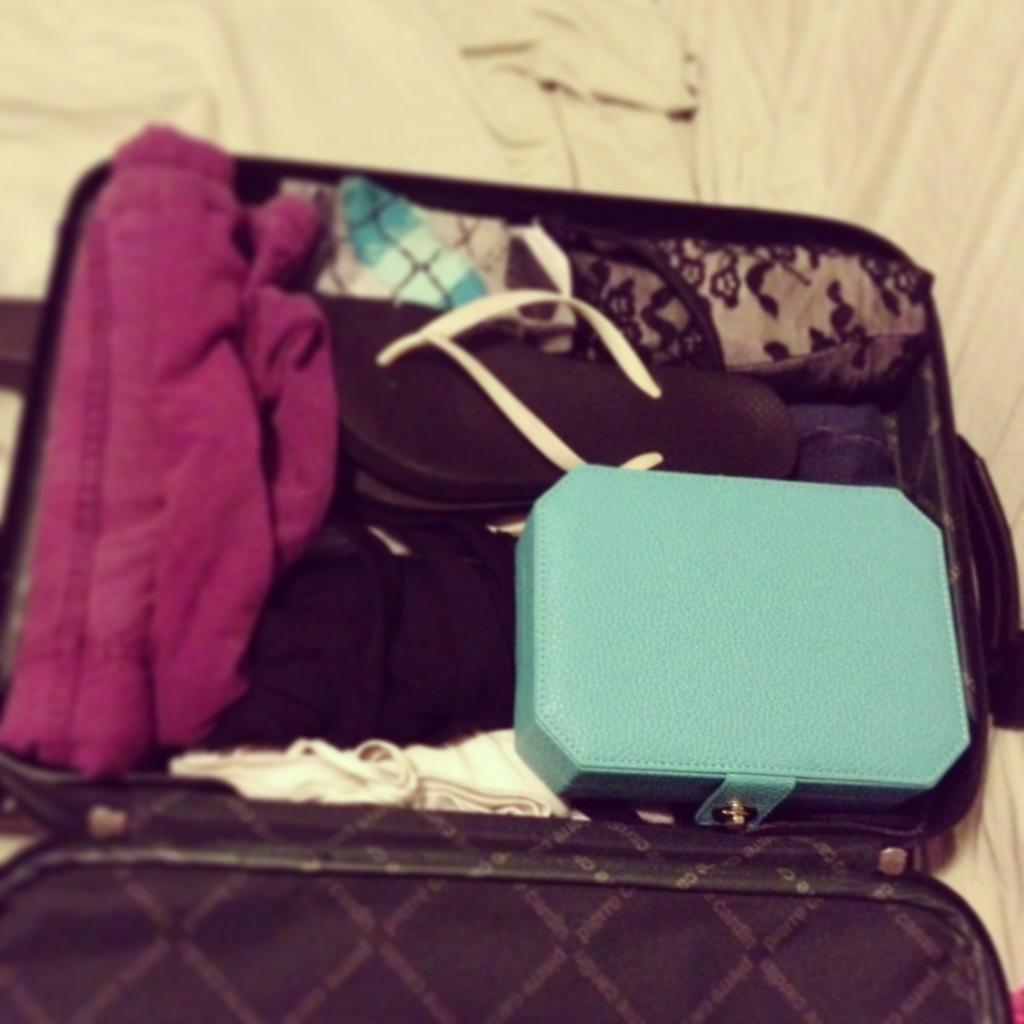What object is present in the image that might be used for carrying items? There is a bag in the image that might be used for carrying items. What type of personal belongings can be seen in the image? There is clothing in the image. What type of footwear is visible in the image? There are slippers in the image. What type of harmony can be heard in the image? There is no audible sound or harmony present in the image, as it is a still image featuring a bag, clothing, and slippers. Can you see a goose in the image? No, there is no goose present in the image. 